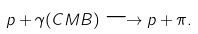Convert formula to latex. <formula><loc_0><loc_0><loc_500><loc_500>p + \gamma ( C M B ) \longrightarrow p + \pi .</formula> 